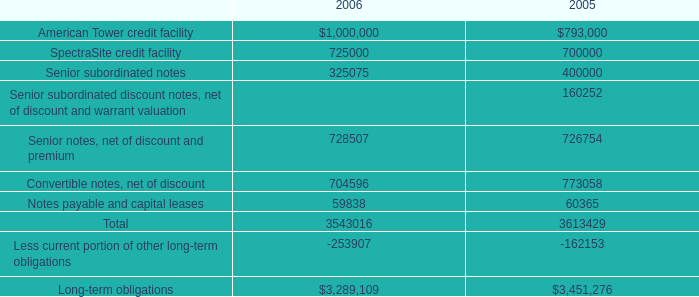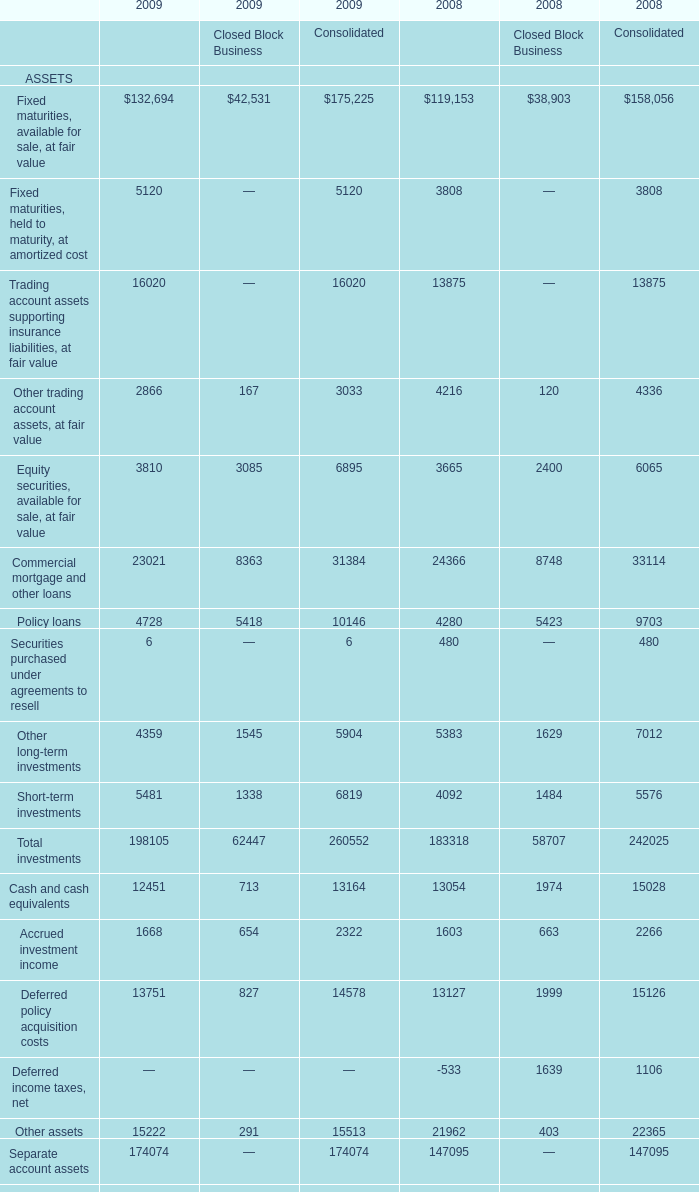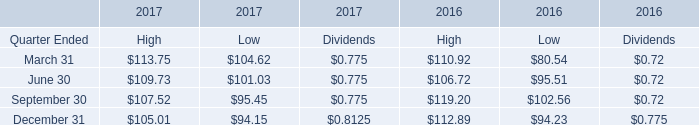what's the total amount of SpectraSite credit facility of 2005, and Separate account assets of 2009 Financial Services Business ? 
Computations: (700000.0 + 174074.0)
Answer: 874074.0. 